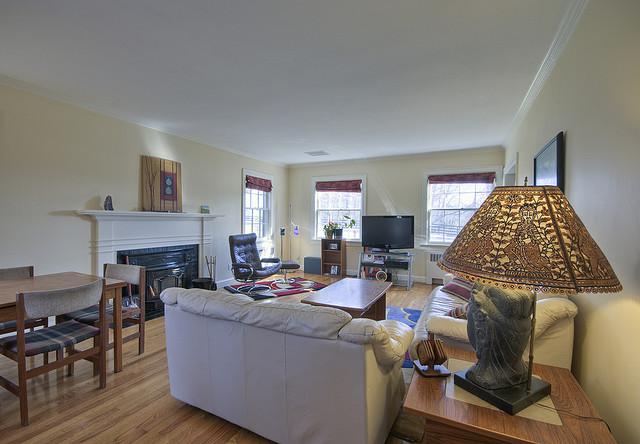What animal is shown?
Be succinct. 0. How many windows are there?
Quick response, please. 3. What type of lamp is on the table to the left?
Give a very brief answer. Table lamp. Are there any bookshelves?
Short answer required. No. Is this a flea market?
Short answer required. No. What room of the house is this?
Answer briefly. Living room. What room is this?
Short answer required. Living room. 